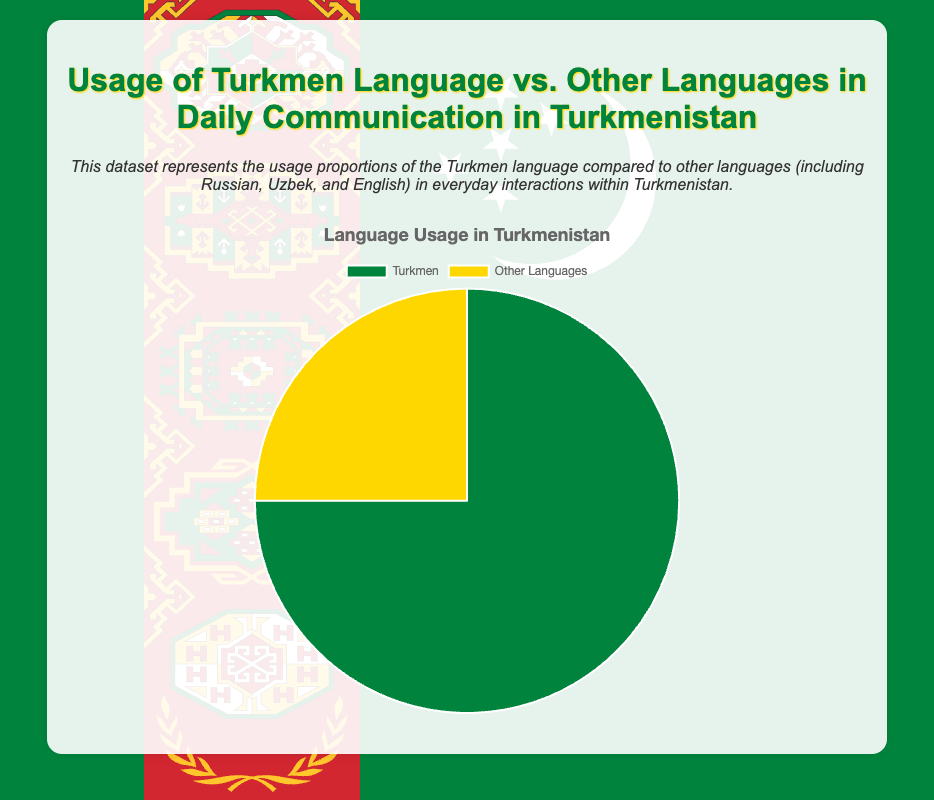Which language has the highest usage percentage in daily communication in Turkmenistan? The pie chart shows two segments representing language usage. The green segment represents the Turkmen language, and it covers 75% of the chart, which is larger than the yellow segment for Other Languages.
Answer: Turkmen What is the usage percentage of languages other than Turkmen in daily communication? The pie chart has a segment labeled "Other Languages," covering 25% of the chart. This directly provides the usage percentage for other languages.
Answer: 25% How many times greater is the usage of Turkmen compared to other languages in daily communication? Turkmen usage is 75%, while other languages usage is 25%. To find how many times greater Turkmen usage is, divide 75 by 25: 75/25 = 3.
Answer: 3 times If 100 people were surveyed, how many of them primarily use Turkmen in daily communication? With Turkmen usage at 75%, multiply 100 by 0.75 to find the number of people: 100 * 0.75 = 75.
Answer: 75 The green segment represents which language and what percentage? In the pie chart, the green segment corresponds to the Turkmen language and accounts for 75% of the pie.
Answer: Turkmen, 75% What would the combined percentage be if another 10% started using Turkmen for daily communication instead of other languages? Currently, Turkmen usage is at 75%, and other languages are at 25%. If 10% from other languages switch to Turkmen, Turkmen usage would be 75% + 10% = 85%, and other languages would be 25% - 10% = 15%.
Answer: Turkmen: 85%, Other Languages: 15% What is the ratio of Turkmen language usage to the usage of other languages? Turkmen language usage is 75%, and other languages usage is 25%. The ratio can be calculated as 75:25, which can be simplified to 3:1.
Answer: 3:1 What color represents the section with the least usage percentage? The pie chart uses yellow to represent "Other Languages," which has the least usage percentage at 25%.
Answer: Yellow 